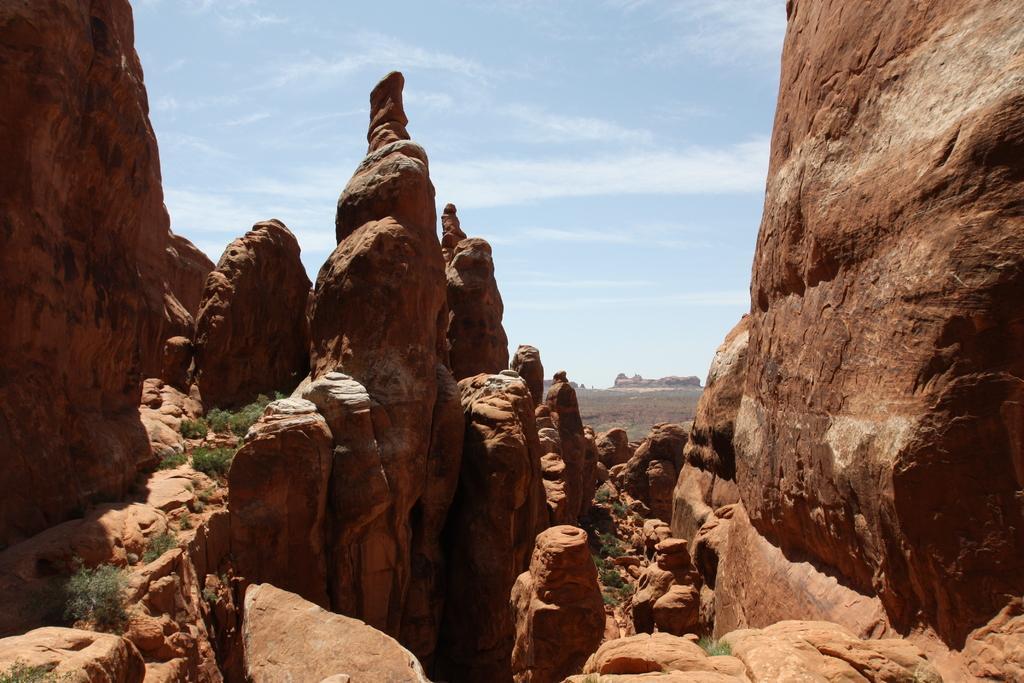Describe this image in one or two sentences. In this image we can see many books, there is grass, there is sky at the top. 